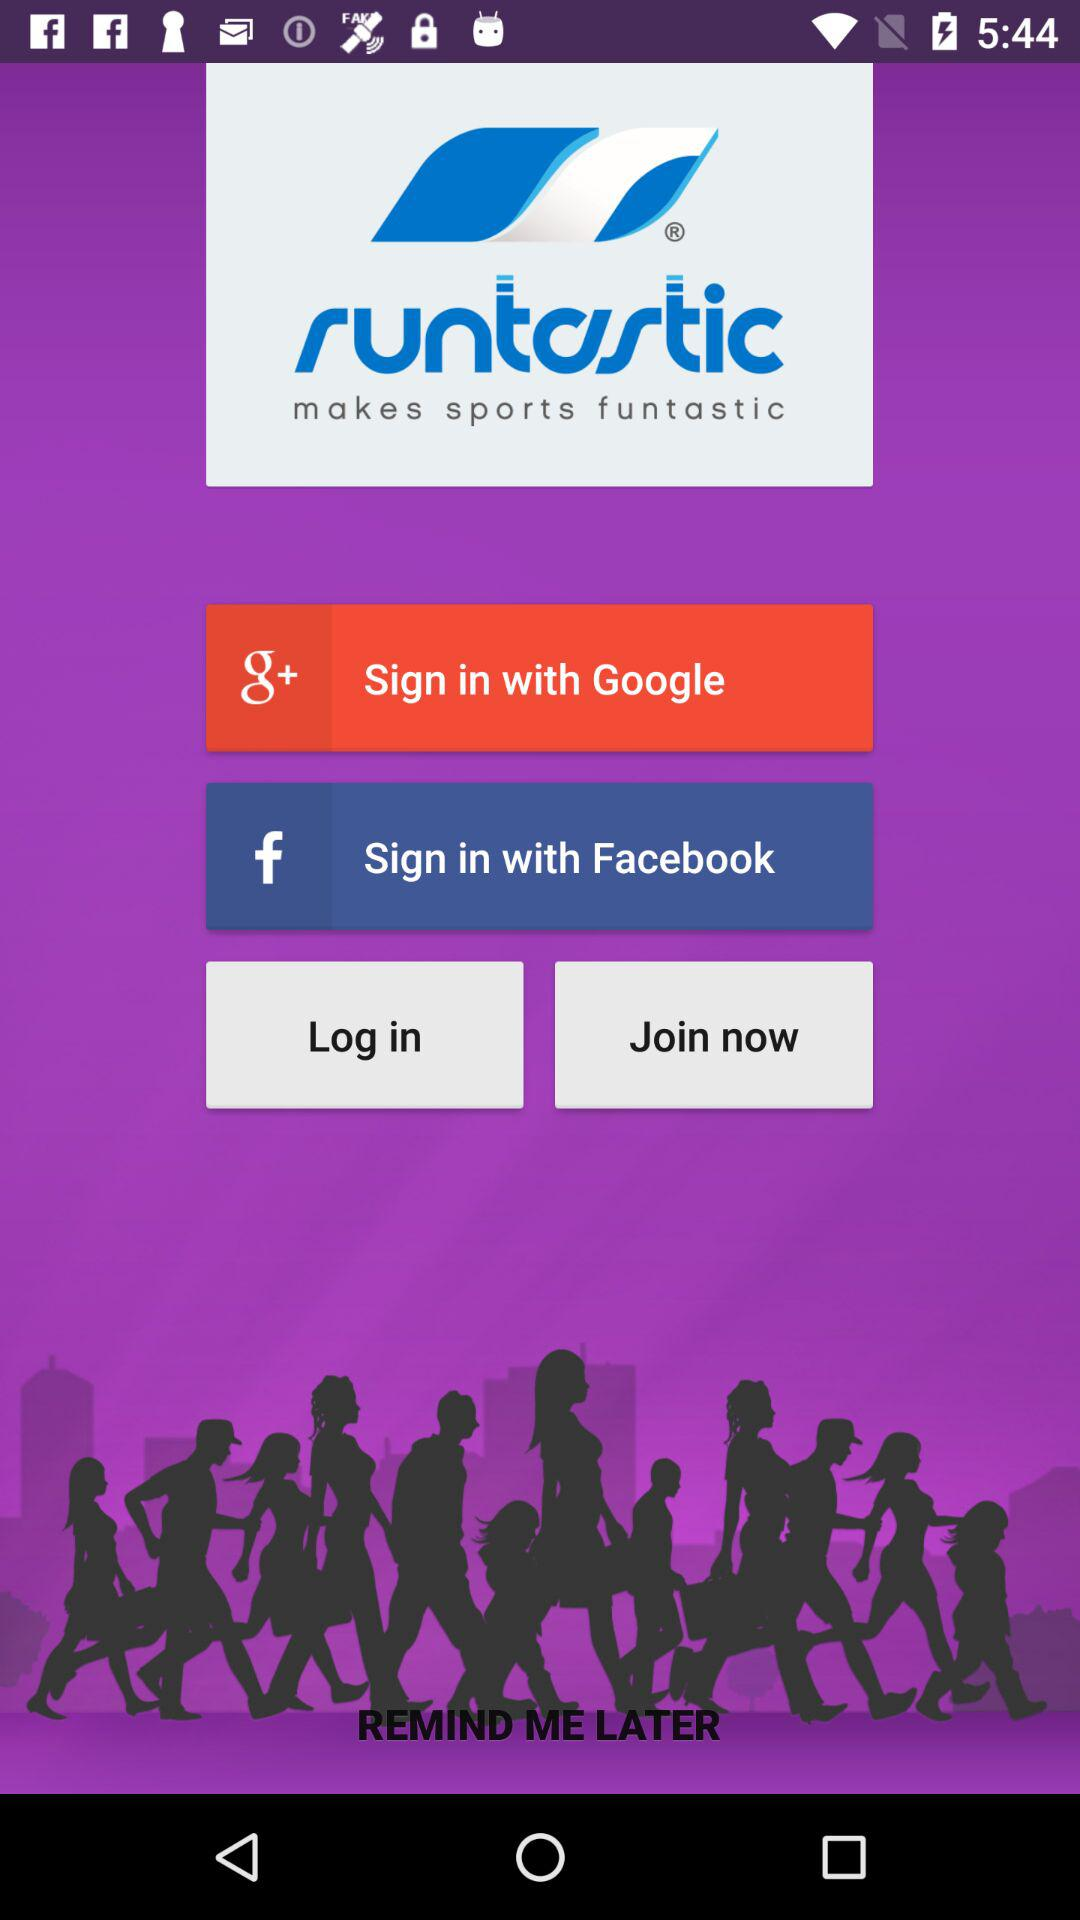What is the application name? The application name is "runtastic". 